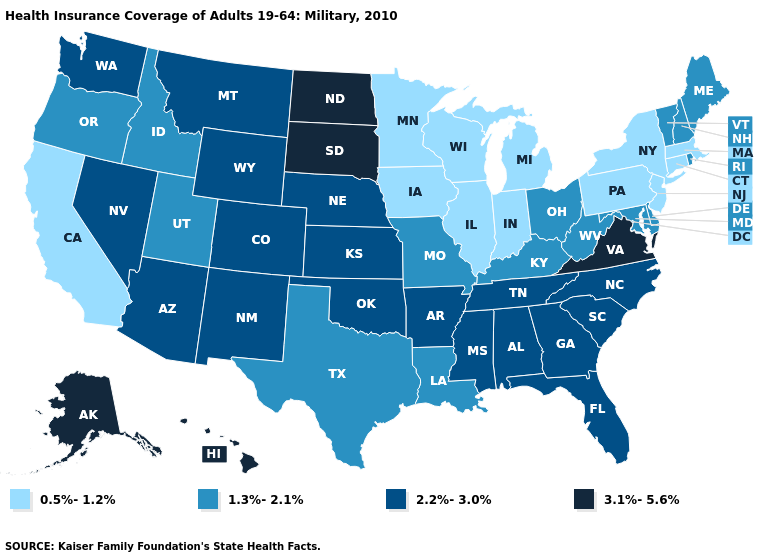Name the states that have a value in the range 0.5%-1.2%?
Write a very short answer. California, Connecticut, Illinois, Indiana, Iowa, Massachusetts, Michigan, Minnesota, New Jersey, New York, Pennsylvania, Wisconsin. Which states have the lowest value in the USA?
Concise answer only. California, Connecticut, Illinois, Indiana, Iowa, Massachusetts, Michigan, Minnesota, New Jersey, New York, Pennsylvania, Wisconsin. Does Louisiana have the same value as Washington?
Quick response, please. No. What is the value of Tennessee?
Answer briefly. 2.2%-3.0%. What is the value of Indiana?
Short answer required. 0.5%-1.2%. What is the value of Delaware?
Concise answer only. 1.3%-2.1%. Does North Dakota have a higher value than Virginia?
Give a very brief answer. No. Name the states that have a value in the range 0.5%-1.2%?
Concise answer only. California, Connecticut, Illinois, Indiana, Iowa, Massachusetts, Michigan, Minnesota, New Jersey, New York, Pennsylvania, Wisconsin. Is the legend a continuous bar?
Give a very brief answer. No. Does Virginia have the highest value in the South?
Keep it brief. Yes. Does Pennsylvania have the lowest value in the USA?
Short answer required. Yes. Does Louisiana have the highest value in the USA?
Give a very brief answer. No. Which states have the lowest value in the USA?
Answer briefly. California, Connecticut, Illinois, Indiana, Iowa, Massachusetts, Michigan, Minnesota, New Jersey, New York, Pennsylvania, Wisconsin. Name the states that have a value in the range 2.2%-3.0%?
Write a very short answer. Alabama, Arizona, Arkansas, Colorado, Florida, Georgia, Kansas, Mississippi, Montana, Nebraska, Nevada, New Mexico, North Carolina, Oklahoma, South Carolina, Tennessee, Washington, Wyoming. Name the states that have a value in the range 1.3%-2.1%?
Be succinct. Delaware, Idaho, Kentucky, Louisiana, Maine, Maryland, Missouri, New Hampshire, Ohio, Oregon, Rhode Island, Texas, Utah, Vermont, West Virginia. 